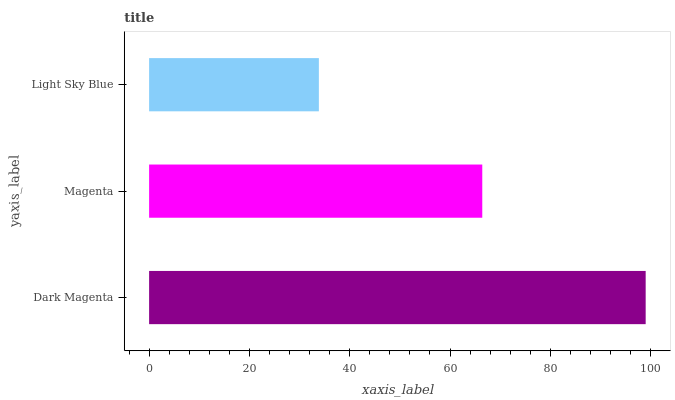Is Light Sky Blue the minimum?
Answer yes or no. Yes. Is Dark Magenta the maximum?
Answer yes or no. Yes. Is Magenta the minimum?
Answer yes or no. No. Is Magenta the maximum?
Answer yes or no. No. Is Dark Magenta greater than Magenta?
Answer yes or no. Yes. Is Magenta less than Dark Magenta?
Answer yes or no. Yes. Is Magenta greater than Dark Magenta?
Answer yes or no. No. Is Dark Magenta less than Magenta?
Answer yes or no. No. Is Magenta the high median?
Answer yes or no. Yes. Is Magenta the low median?
Answer yes or no. Yes. Is Light Sky Blue the high median?
Answer yes or no. No. Is Dark Magenta the low median?
Answer yes or no. No. 